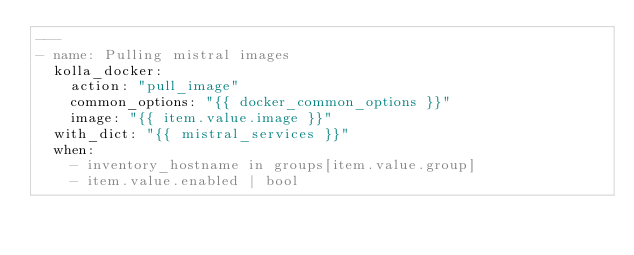Convert code to text. <code><loc_0><loc_0><loc_500><loc_500><_YAML_>---
- name: Pulling mistral images
  kolla_docker:
    action: "pull_image"
    common_options: "{{ docker_common_options }}"
    image: "{{ item.value.image }}"
  with_dict: "{{ mistral_services }}"
  when:
    - inventory_hostname in groups[item.value.group]
    - item.value.enabled | bool
</code> 